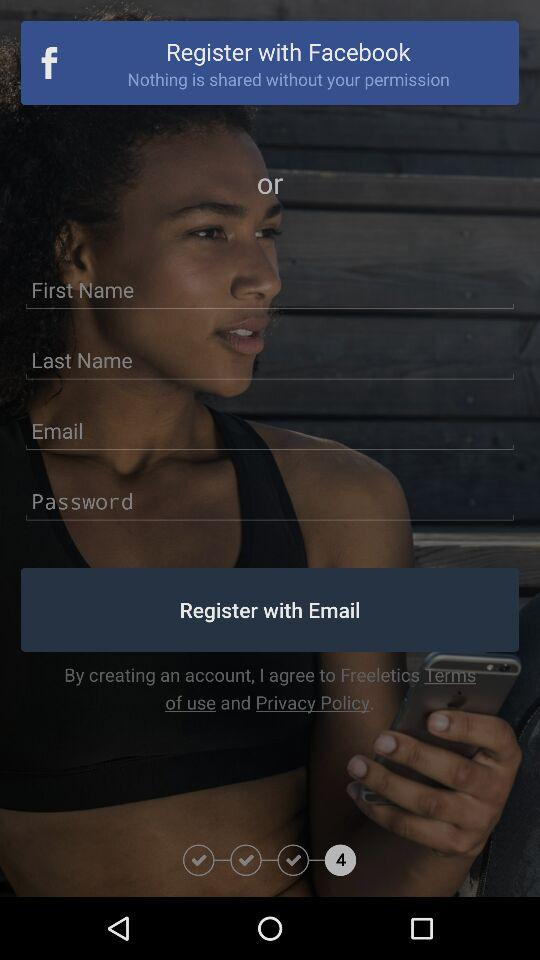What is the name of the application?
When the provided information is insufficient, respond with <no answer>. <no answer> 